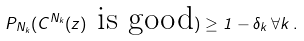Convert formula to latex. <formula><loc_0><loc_0><loc_500><loc_500>P _ { N _ { k } } ( C ^ { N _ { k } } ( z ) \text { is good} ) \geq 1 - \delta _ { k } \, \forall k \, .</formula> 